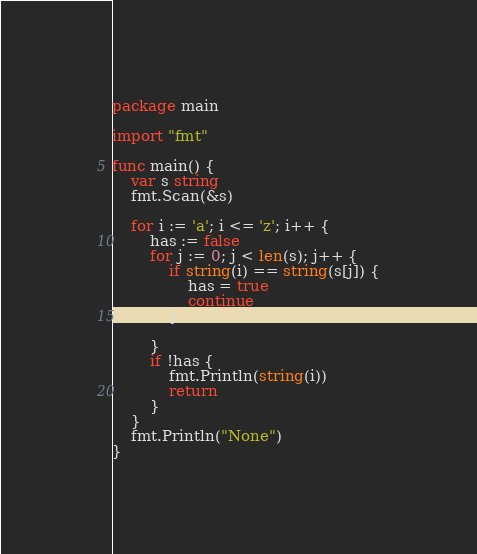Convert code to text. <code><loc_0><loc_0><loc_500><loc_500><_Go_>package main

import "fmt"

func main() {
	var s string
	fmt.Scan(&s)
	
	for i := 'a'; i <= 'z'; i++ {
		has := false
		for j := 0; j < len(s); j++ {
        	if string(i) == string(s[j]) {
				has = true
            	continue
			}
		
		}
		if !has {
        	fmt.Println(string(i))
        	return
		}
	}
	fmt.Println("None")
}</code> 